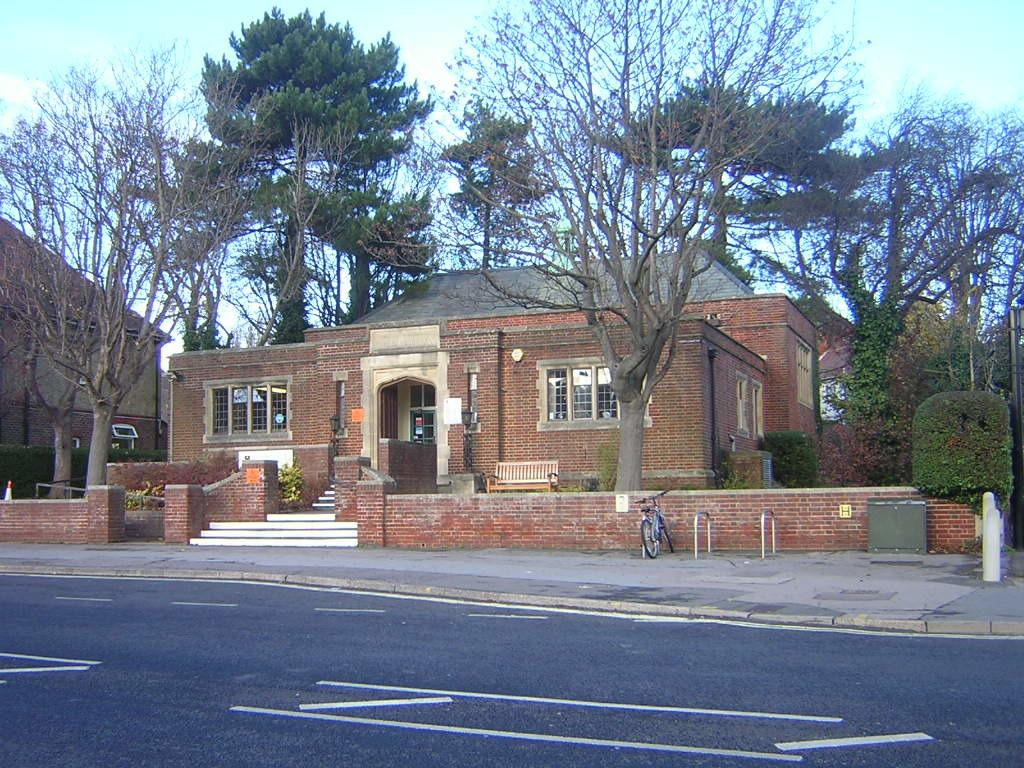What type of structure is visible in the image? There is a house in the image. What can be seen surrounding the house? There are many trees around the house. Is there any mode of transportation visible in the image? Yes, there is a cycle parked in front of the house. Who is the creator of the duck that can be seen in the image? There is no duck present in the image, so it is not possible to determine who its creator might be. 